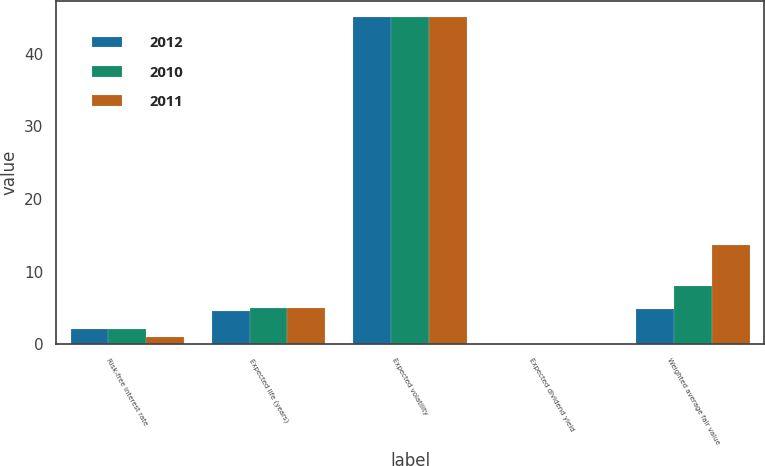Convert chart to OTSL. <chart><loc_0><loc_0><loc_500><loc_500><stacked_bar_chart><ecel><fcel>Risk-free interest rate<fcel>Expected life (years)<fcel>Expected volatility<fcel>Expected dividend yield<fcel>Weighted average fair value<nl><fcel>2012<fcel>2.1<fcel>4.6<fcel>45<fcel>0<fcel>4.78<nl><fcel>2010<fcel>2.1<fcel>5<fcel>45<fcel>0<fcel>8.04<nl><fcel>2011<fcel>1<fcel>5<fcel>45<fcel>0<fcel>13.7<nl></chart> 